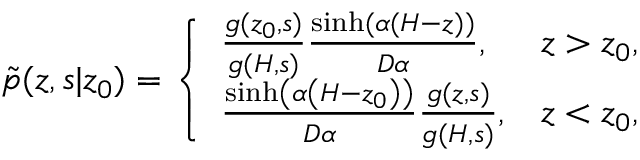<formula> <loc_0><loc_0><loc_500><loc_500>\begin{array} { r } { \tilde { p } ( z , s | z _ { 0 } ) = \left \{ \begin{array} { l l } { \frac { g ( z _ { 0 } , s ) } { g ( H , s ) } \frac { \sinh ( \alpha ( H - z ) ) } { D \alpha } , } & { z > z _ { 0 } , } \\ { \frac { \sinh \left ( \alpha \left ( H - z _ { 0 } \right ) \right ) } { D \alpha } \frac { g ( z , s ) } { g ( H , s ) } , } & { z < z _ { 0 } , } \end{array} } \end{array}</formula> 